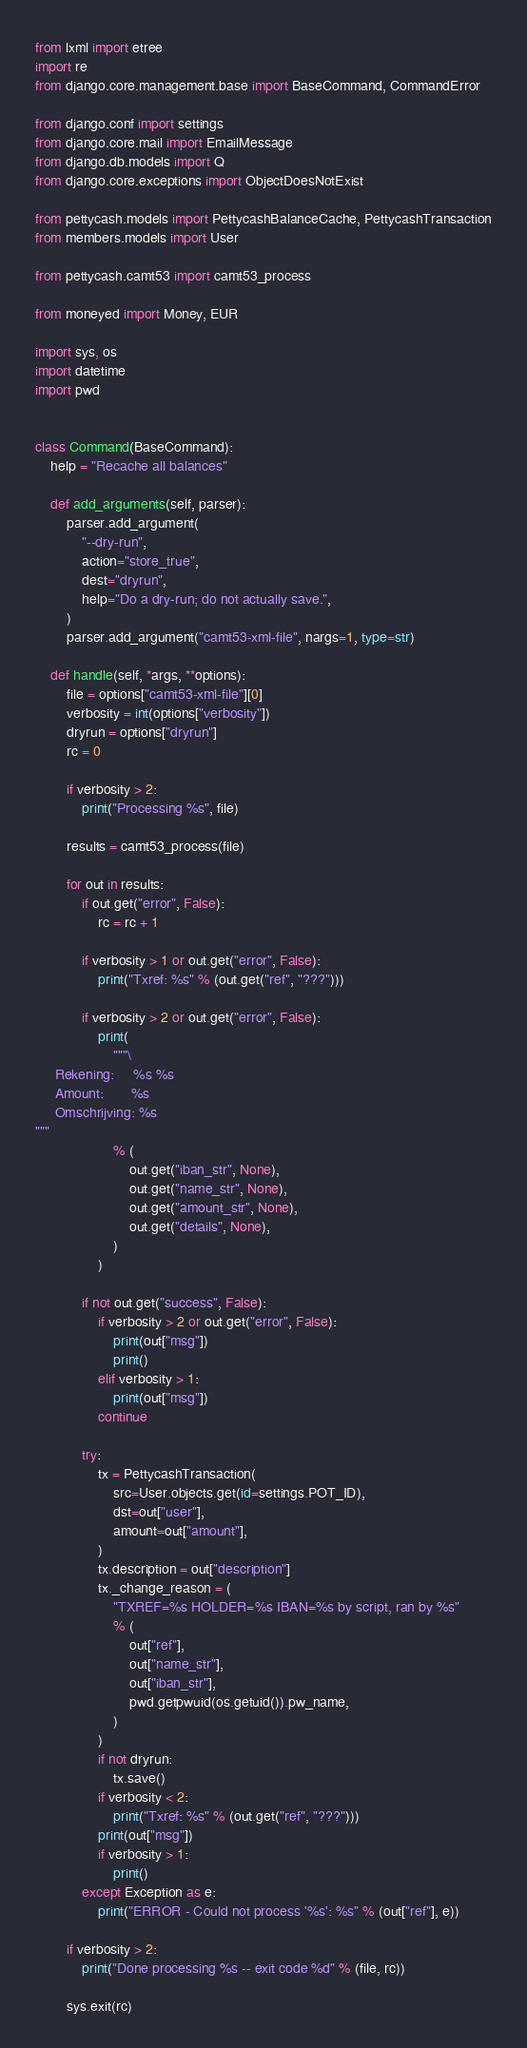Convert code to text. <code><loc_0><loc_0><loc_500><loc_500><_Python_>from lxml import etree
import re
from django.core.management.base import BaseCommand, CommandError

from django.conf import settings
from django.core.mail import EmailMessage
from django.db.models import Q
from django.core.exceptions import ObjectDoesNotExist

from pettycash.models import PettycashBalanceCache, PettycashTransaction
from members.models import User

from pettycash.camt53 import camt53_process

from moneyed import Money, EUR

import sys, os
import datetime
import pwd


class Command(BaseCommand):
    help = "Recache all balances"

    def add_arguments(self, parser):
        parser.add_argument(
            "--dry-run",
            action="store_true",
            dest="dryrun",
            help="Do a dry-run; do not actually save.",
        )
        parser.add_argument("camt53-xml-file", nargs=1, type=str)

    def handle(self, *args, **options):
        file = options["camt53-xml-file"][0]
        verbosity = int(options["verbosity"])
        dryrun = options["dryrun"]
        rc = 0

        if verbosity > 2:
            print("Processing %s", file)

        results = camt53_process(file)

        for out in results:
            if out.get("error", False):
                rc = rc + 1

            if verbosity > 1 or out.get("error", False):
                print("Txref: %s" % (out.get("ref", "???")))

            if verbosity > 2 or out.get("error", False):
                print(
                    """\
     Rekening:     %s %s
     Amount:       %s
     Omschrijving: %s
"""
                    % (
                        out.get("iban_str", None),
                        out.get("name_str", None),
                        out.get("amount_str", None),
                        out.get("details", None),
                    )
                )

            if not out.get("success", False):
                if verbosity > 2 or out.get("error", False):
                    print(out["msg"])
                    print()
                elif verbosity > 1:
                    print(out["msg"])
                continue

            try:
                tx = PettycashTransaction(
                    src=User.objects.get(id=settings.POT_ID),
                    dst=out["user"],
                    amount=out["amount"],
                )
                tx.description = out["description"]
                tx._change_reason = (
                    "TXREF=%s HOLDER=%s IBAN=%s by script, ran by %s"
                    % (
                        out["ref"],
                        out["name_str"],
                        out["iban_str"],
                        pwd.getpwuid(os.getuid()).pw_name,
                    )
                )
                if not dryrun:
                    tx.save()
                if verbosity < 2:
                    print("Txref: %s" % (out.get("ref", "???")))
                print(out["msg"])
                if verbosity > 1:
                    print()
            except Exception as e:
                print("ERROR - Could not process '%s': %s" % (out["ref"], e))

        if verbosity > 2:
            print("Done processing %s -- exit code %d" % (file, rc))

        sys.exit(rc)
</code> 